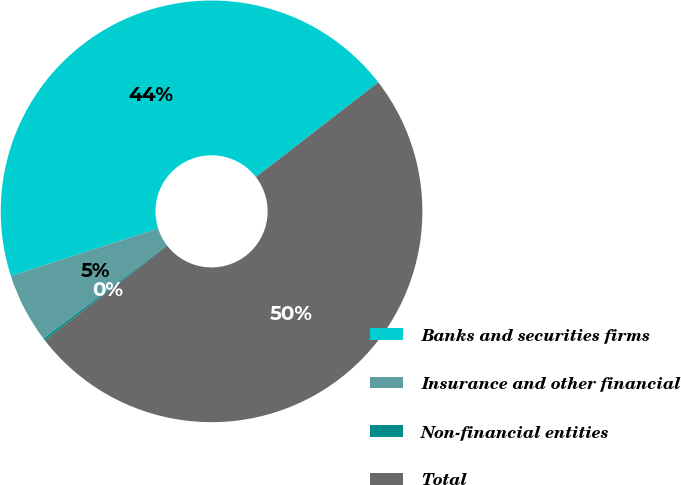<chart> <loc_0><loc_0><loc_500><loc_500><pie_chart><fcel>Banks and securities firms<fcel>Insurance and other financial<fcel>Non-financial entities<fcel>Total<nl><fcel>44.48%<fcel>5.36%<fcel>0.17%<fcel>50.0%<nl></chart> 